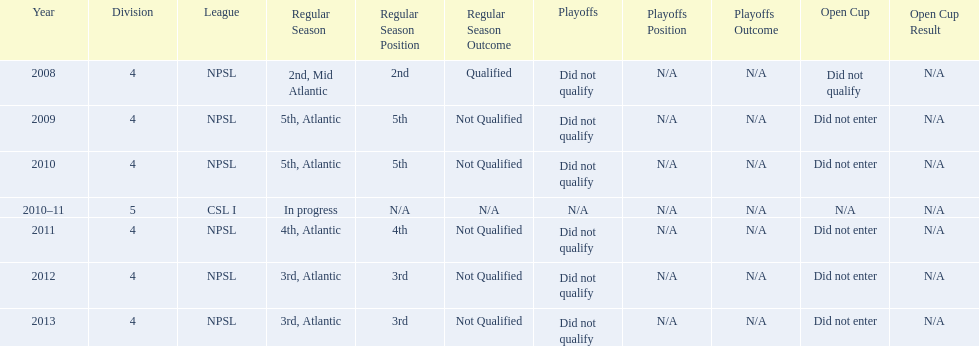In which most recent year did they secure 3rd place? 2013. 